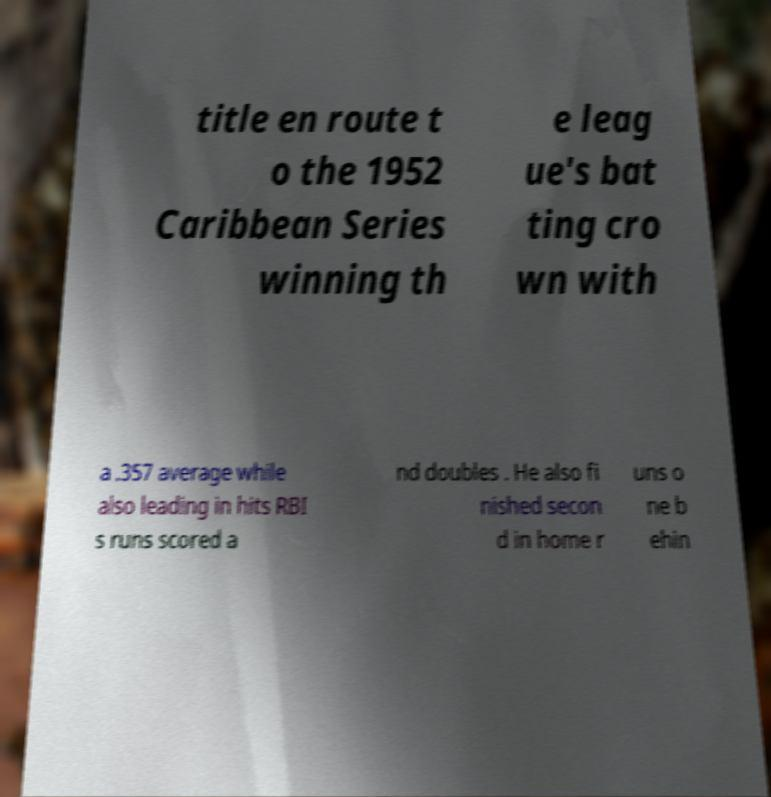Could you assist in decoding the text presented in this image and type it out clearly? title en route t o the 1952 Caribbean Series winning th e leag ue's bat ting cro wn with a .357 average while also leading in hits RBI s runs scored a nd doubles . He also fi nished secon d in home r uns o ne b ehin 